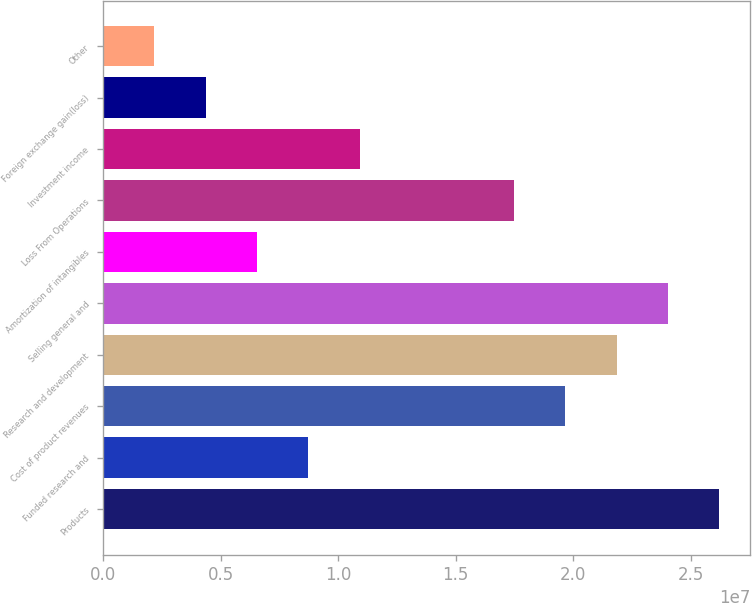Convert chart to OTSL. <chart><loc_0><loc_0><loc_500><loc_500><bar_chart><fcel>Products<fcel>Funded research and<fcel>Cost of product revenues<fcel>Research and development<fcel>Selling general and<fcel>Amortization of intangibles<fcel>Loss From Operations<fcel>Investment income<fcel>Foreign exchange gain(loss)<fcel>Other<nl><fcel>2.62137e+07<fcel>8.7379e+06<fcel>1.96603e+07<fcel>2.18448e+07<fcel>2.40292e+07<fcel>6.55343e+06<fcel>1.74758e+07<fcel>1.09224e+07<fcel>4.36895e+06<fcel>2.18448e+06<nl></chart> 